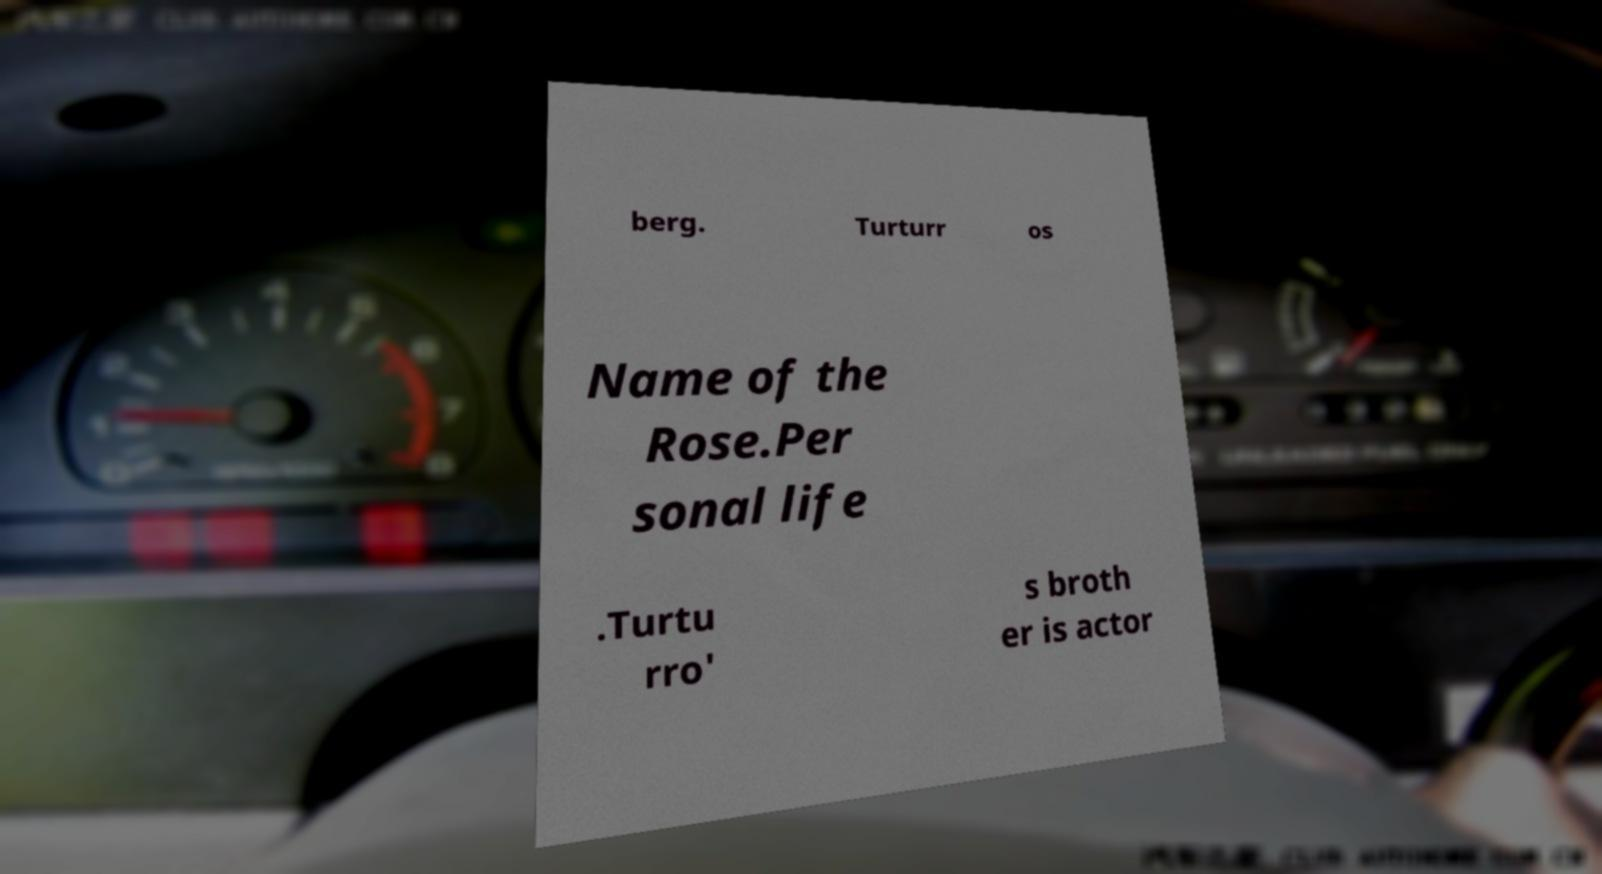Please read and relay the text visible in this image. What does it say? berg. Turturr os Name of the Rose.Per sonal life .Turtu rro' s broth er is actor 